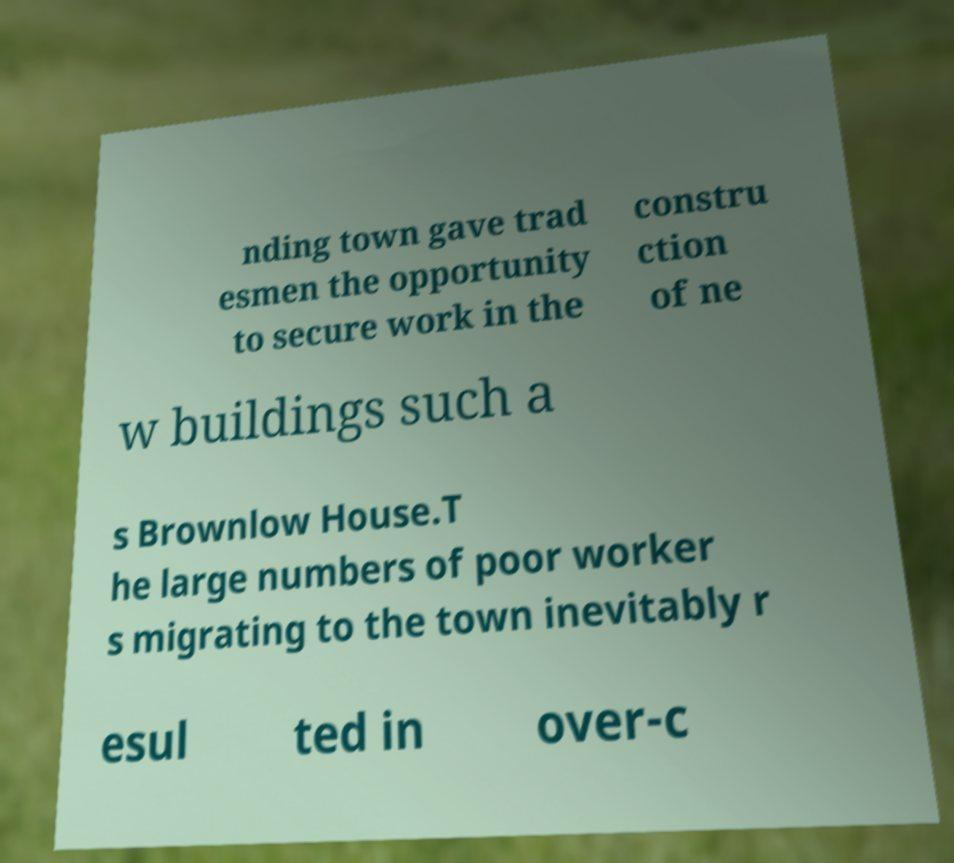I need the written content from this picture converted into text. Can you do that? nding town gave trad esmen the opportunity to secure work in the constru ction of ne w buildings such a s Brownlow House.T he large numbers of poor worker s migrating to the town inevitably r esul ted in over-c 